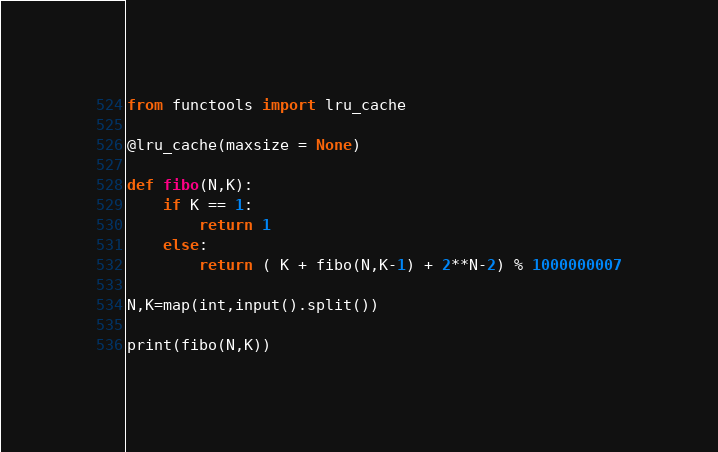Convert code to text. <code><loc_0><loc_0><loc_500><loc_500><_Python_>from functools import lru_cache

@lru_cache(maxsize = None)

def fibo(N,K):
    if K == 1:
        return 1
    else:
        return ( K + fibo(N,K-1) + 2**N-2) % 1000000007
      
N,K=map(int,input().split())

print(fibo(N,K))</code> 